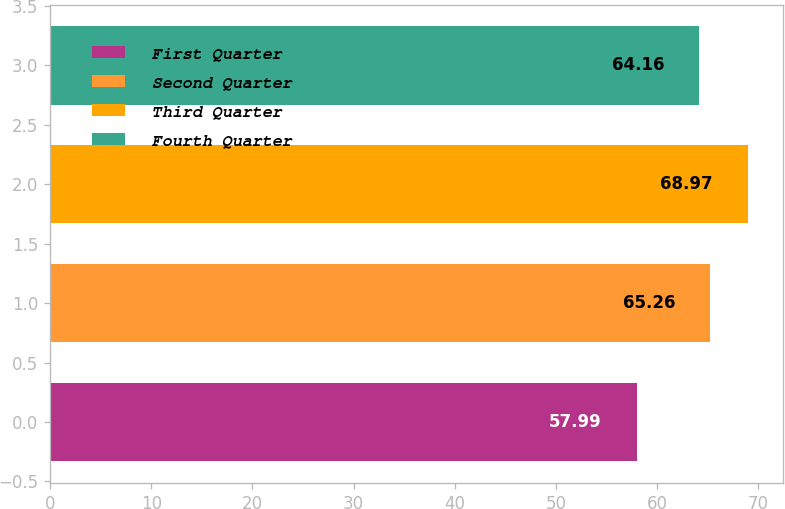<chart> <loc_0><loc_0><loc_500><loc_500><bar_chart><fcel>First Quarter<fcel>Second Quarter<fcel>Third Quarter<fcel>Fourth Quarter<nl><fcel>57.99<fcel>65.26<fcel>68.97<fcel>64.16<nl></chart> 